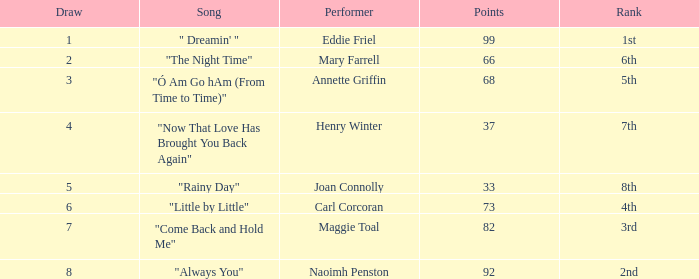What is the typical amount of points when the rank is 7th and the draw is under 4? None. 